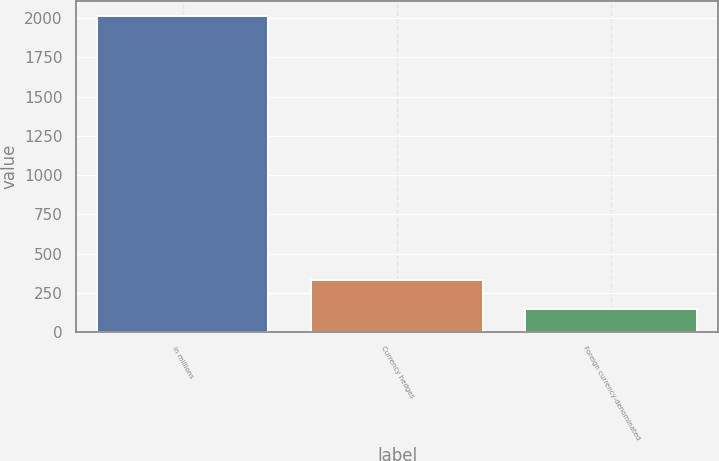Convert chart to OTSL. <chart><loc_0><loc_0><loc_500><loc_500><bar_chart><fcel>in millions<fcel>Currency hedges<fcel>Foreign currency-denominated<nl><fcel>2011<fcel>333.4<fcel>147<nl></chart> 